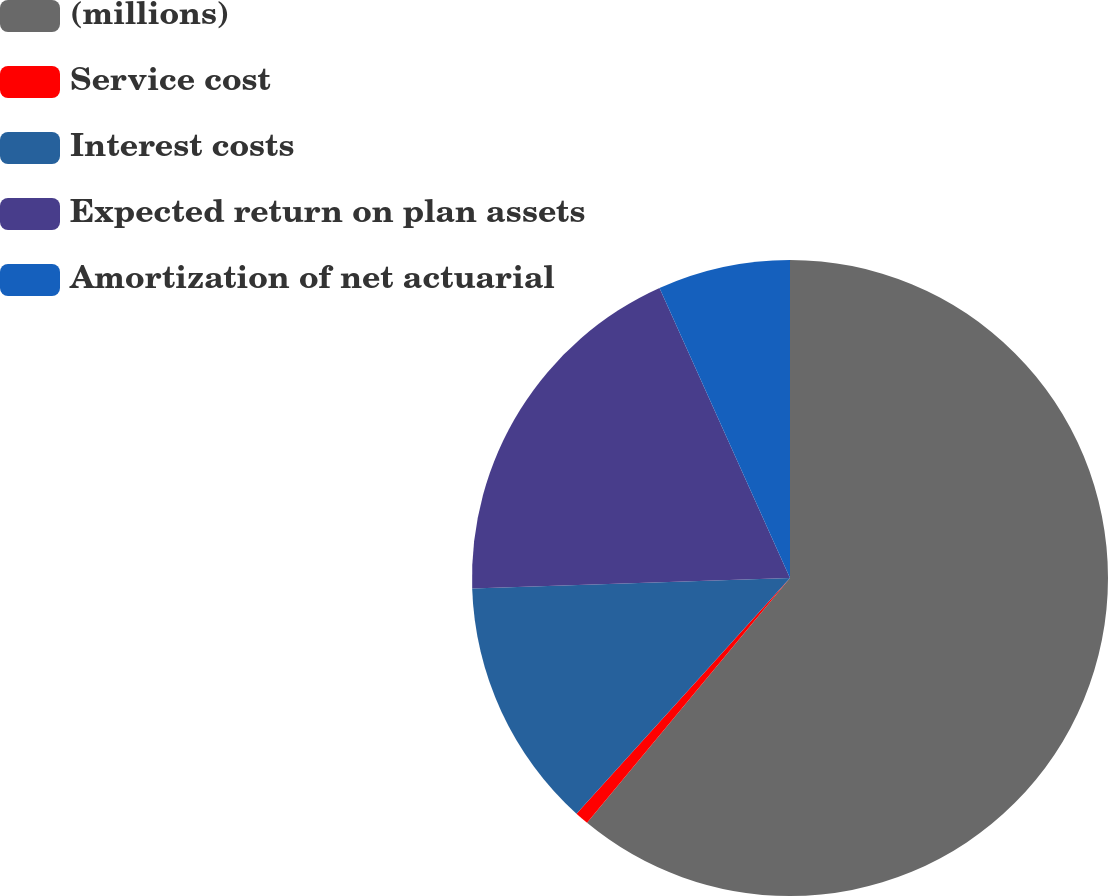<chart> <loc_0><loc_0><loc_500><loc_500><pie_chart><fcel>(millions)<fcel>Service cost<fcel>Interest costs<fcel>Expected return on plan assets<fcel>Amortization of net actuarial<nl><fcel>61.01%<fcel>0.7%<fcel>12.76%<fcel>18.79%<fcel>6.73%<nl></chart> 